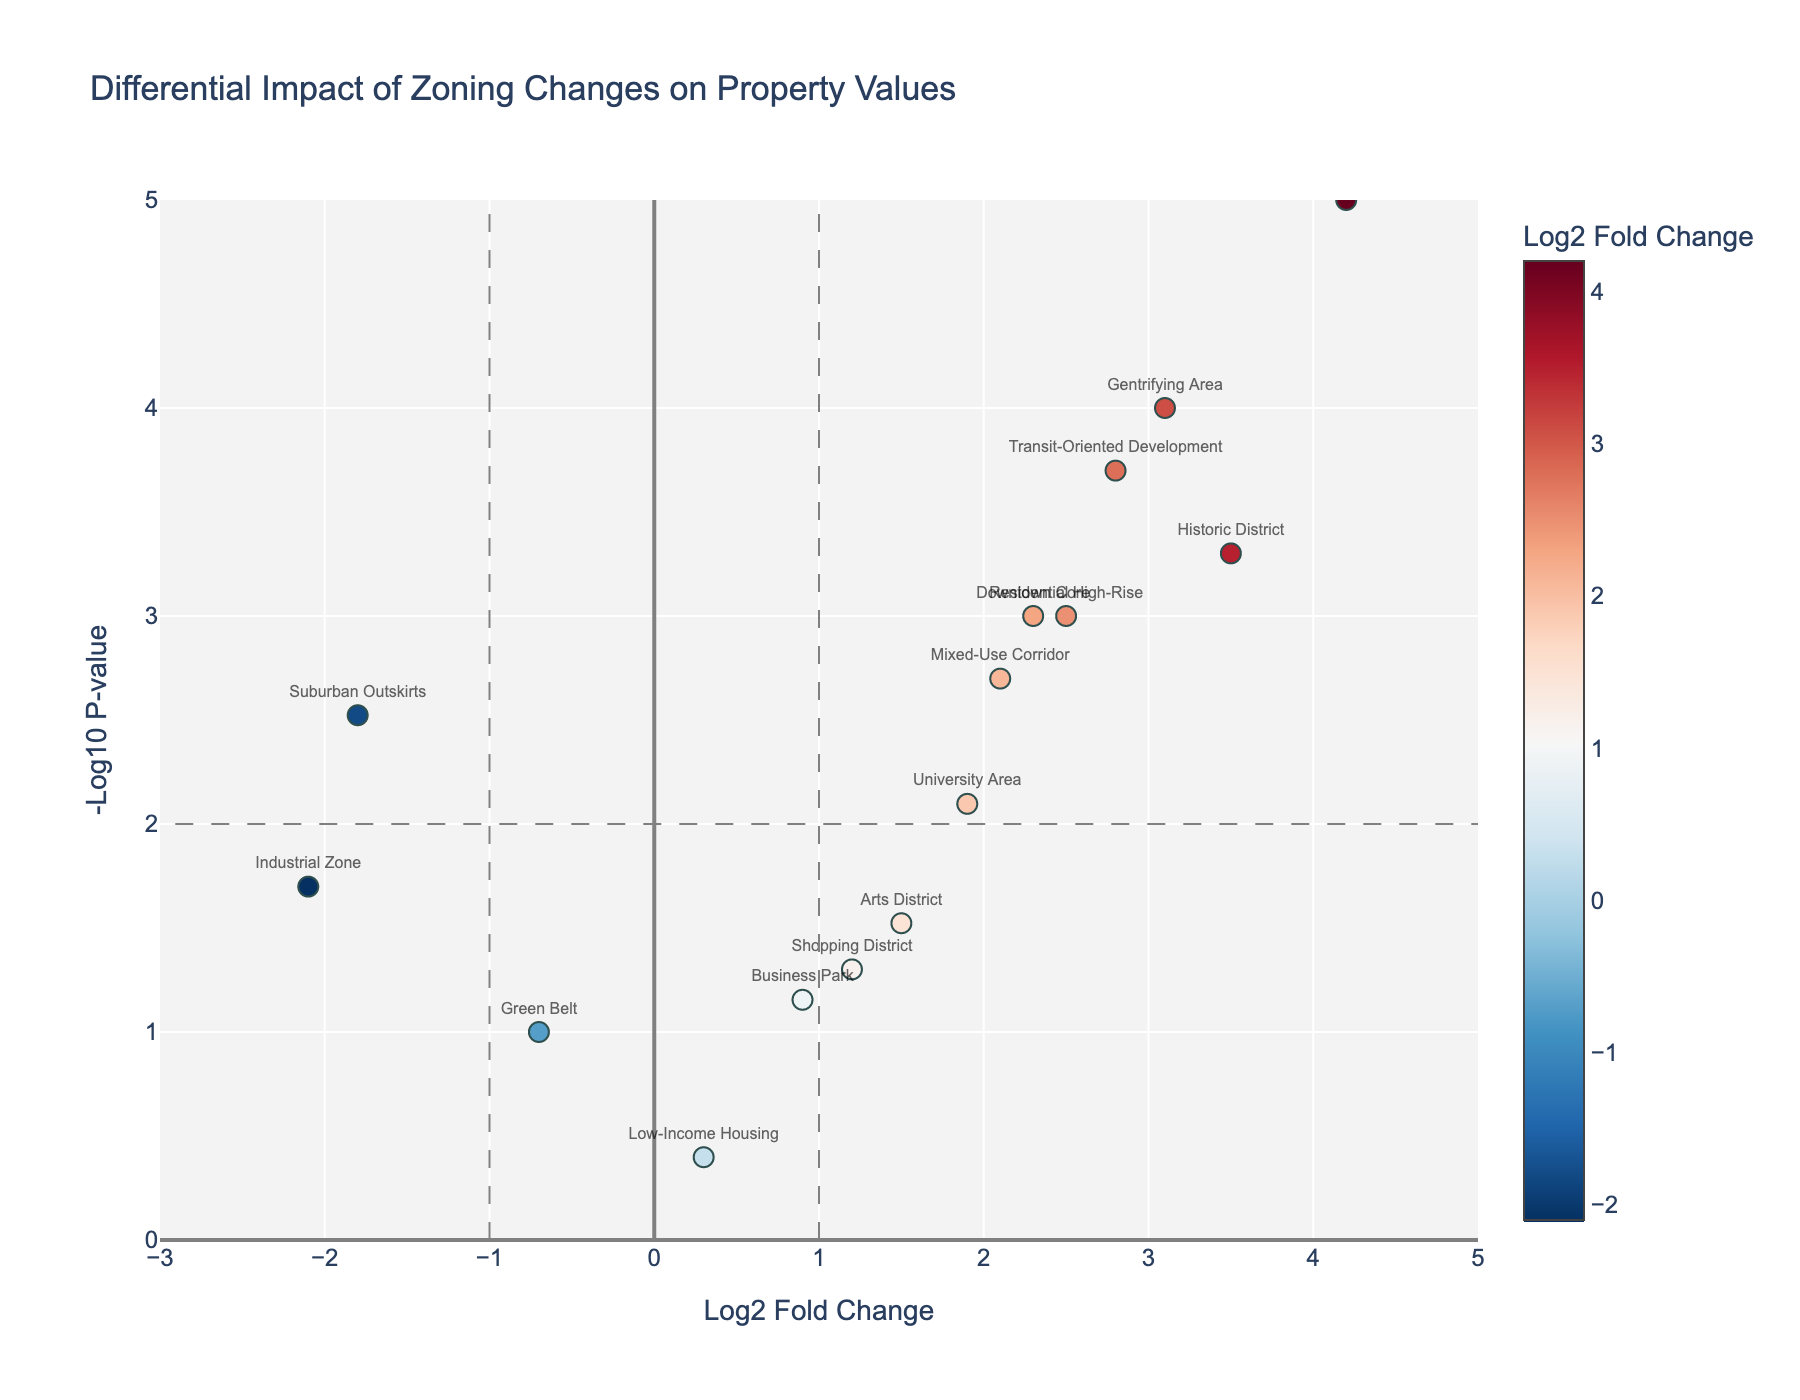What does the title of the plot indicate? The title "Differential Impact of Zoning Changes on Property Values" informs that the plot showcases how zoning changes affect property values differently across various neighborhoods.
Answer: Differential Impact of Zoning Changes on Property Values What do the x and y axes represent? The x-axis represents the Log2 Fold Change in property values due to zoning changes, while the y-axis represents the -Log10 of the p-values, indicating statistical significance.
Answer: Log2 Fold Change (x-axis) and -Log10 P-value (y-axis) Which neighborhood shows the highest impact in property value change? The "Waterfront" neighborhood has the highest Log2 Fold Change value of 4.2, making it the neighborhood with the greatest impact.
Answer: Waterfront How many neighborhoods have a statistically significant impact with a p-value < 0.01 and a log2 fold change > 1? By examining the data points to the right of the x=1 line and above the y=2 line, there are 6 neighborhoods that meet this criteria.
Answer: 6 Which neighborhood shows the greatest negative impact on property values? The "Industrial Zone" neighborhood has the most negative Log2 Fold Change value of -2.1, indicating the greatest negative impact.
Answer: Industrial Zone How many neighborhoods have a log2 fold change between -1 and 1? By counting the data points between the x-values of -1 and 1, there are 4 neighborhoods in this range.
Answer: 4 What is the p-value threshold indicated by the horizontal grey line? The horizontal grey line at y=2 represents a p-value threshold of 0.01, as -Log10(0.01) = 2.
Answer: 0.01 Which neighborhood has a log2 fold change closest to the median of the dataset? Sorting the log2 fold changes in ascending order, the median value is approximately 1.9, and "University Area" matches this value.
Answer: University Area Compared to the "Gentrifying Area," does "Downtown Core" have a higher or lower statistical significance? "Gentrifying Area" has a higher -Log10 P-value at about 4 than "Downtown Core" which has a -Log10 P-value of approximately 3.
Answer: Lower Does the "Arts District" neighborhood have a statistically significant impact? With a p-value of 0.03, the "Arts District" neighborhood does not cross the conventional significance threshold of 0.01.
Answer: No 